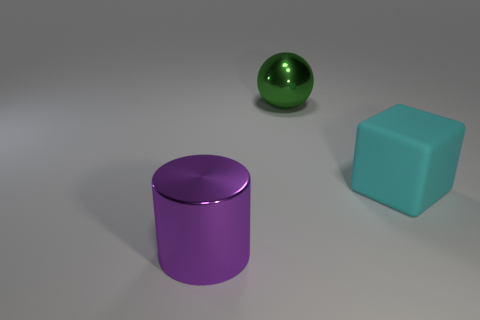There is a large metal thing in front of the matte block; what color is it?
Provide a short and direct response. Purple. How many matte things are either red objects or cyan cubes?
Make the answer very short. 1. What number of purple metal cylinders have the same size as the shiny sphere?
Keep it short and to the point. 1. There is a big object that is left of the cyan matte cube and behind the large purple shiny cylinder; what is its color?
Make the answer very short. Green. How many objects are green shiny balls or large cylinders?
Provide a short and direct response. 2. How many tiny objects are either cyan matte cylinders or cubes?
Your response must be concise. 0. Is there any other thing that is the same color as the large rubber block?
Your answer should be compact. No. There is a thing that is both on the right side of the big metallic cylinder and left of the rubber thing; what size is it?
Your answer should be compact. Large. Do the big thing that is behind the cyan block and the thing that is in front of the big cyan matte thing have the same color?
Provide a short and direct response. No. What number of other objects are the same material as the big cyan object?
Offer a very short reply. 0. 